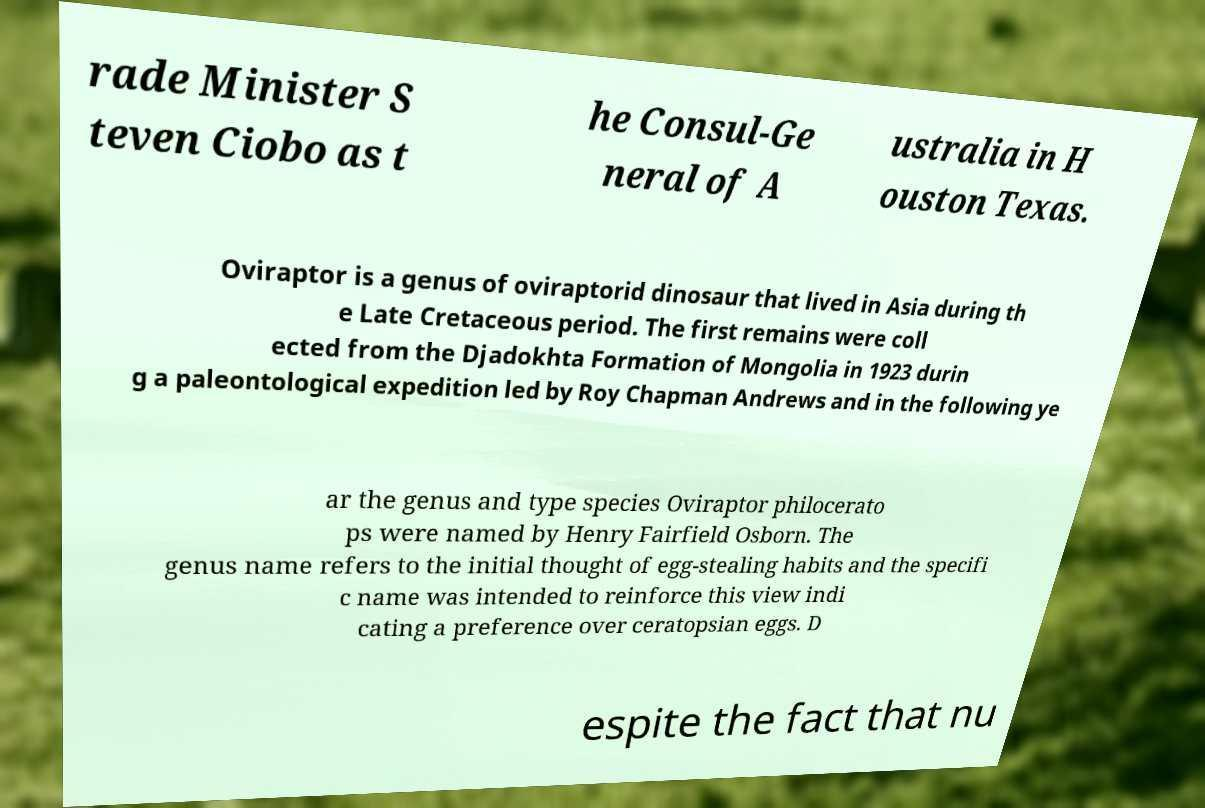I need the written content from this picture converted into text. Can you do that? rade Minister S teven Ciobo as t he Consul-Ge neral of A ustralia in H ouston Texas. Oviraptor is a genus of oviraptorid dinosaur that lived in Asia during th e Late Cretaceous period. The first remains were coll ected from the Djadokhta Formation of Mongolia in 1923 durin g a paleontological expedition led by Roy Chapman Andrews and in the following ye ar the genus and type species Oviraptor philocerato ps were named by Henry Fairfield Osborn. The genus name refers to the initial thought of egg-stealing habits and the specifi c name was intended to reinforce this view indi cating a preference over ceratopsian eggs. D espite the fact that nu 